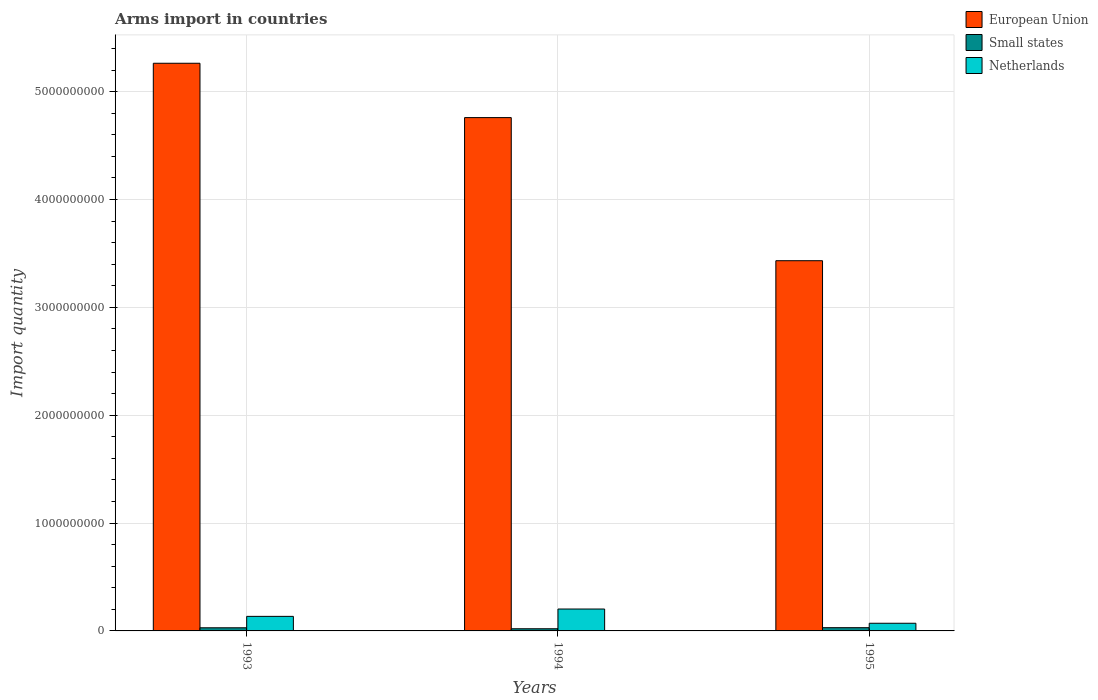How many different coloured bars are there?
Ensure brevity in your answer.  3. Are the number of bars on each tick of the X-axis equal?
Offer a terse response. Yes. What is the label of the 1st group of bars from the left?
Your response must be concise. 1993. What is the total arms import in Small states in 1995?
Keep it short and to the point. 3.00e+07. Across all years, what is the maximum total arms import in Netherlands?
Your answer should be compact. 2.03e+08. Across all years, what is the minimum total arms import in Small states?
Offer a very short reply. 2.00e+07. In which year was the total arms import in Netherlands maximum?
Make the answer very short. 1994. In which year was the total arms import in Small states minimum?
Offer a terse response. 1994. What is the total total arms import in Netherlands in the graph?
Make the answer very short. 4.09e+08. What is the difference between the total arms import in Small states in 1994 and that in 1995?
Provide a short and direct response. -1.00e+07. What is the difference between the total arms import in European Union in 1994 and the total arms import in Small states in 1995?
Your response must be concise. 4.73e+09. What is the average total arms import in Netherlands per year?
Your response must be concise. 1.36e+08. In the year 1993, what is the difference between the total arms import in European Union and total arms import in Netherlands?
Your answer should be compact. 5.13e+09. In how many years, is the total arms import in Netherlands greater than 4600000000?
Your response must be concise. 0. What is the ratio of the total arms import in European Union in 1993 to that in 1994?
Provide a short and direct response. 1.11. Is the difference between the total arms import in European Union in 1993 and 1994 greater than the difference between the total arms import in Netherlands in 1993 and 1994?
Your response must be concise. Yes. What is the difference between the highest and the second highest total arms import in Small states?
Provide a succinct answer. 1.00e+06. What is the difference between the highest and the lowest total arms import in European Union?
Offer a very short reply. 1.83e+09. In how many years, is the total arms import in European Union greater than the average total arms import in European Union taken over all years?
Make the answer very short. 2. Is the sum of the total arms import in Netherlands in 1993 and 1995 greater than the maximum total arms import in Small states across all years?
Ensure brevity in your answer.  Yes. What does the 1st bar from the left in 1994 represents?
Provide a short and direct response. European Union. What does the 1st bar from the right in 1995 represents?
Your answer should be very brief. Netherlands. How many bars are there?
Your answer should be very brief. 9. Are all the bars in the graph horizontal?
Provide a short and direct response. No. How many years are there in the graph?
Provide a succinct answer. 3. What is the difference between two consecutive major ticks on the Y-axis?
Give a very brief answer. 1.00e+09. Are the values on the major ticks of Y-axis written in scientific E-notation?
Give a very brief answer. No. Does the graph contain any zero values?
Offer a terse response. No. How many legend labels are there?
Keep it short and to the point. 3. How are the legend labels stacked?
Offer a very short reply. Vertical. What is the title of the graph?
Give a very brief answer. Arms import in countries. What is the label or title of the Y-axis?
Keep it short and to the point. Import quantity. What is the Import quantity of European Union in 1993?
Your answer should be very brief. 5.26e+09. What is the Import quantity of Small states in 1993?
Give a very brief answer. 2.90e+07. What is the Import quantity of Netherlands in 1993?
Give a very brief answer. 1.35e+08. What is the Import quantity in European Union in 1994?
Your response must be concise. 4.76e+09. What is the Import quantity of Small states in 1994?
Offer a very short reply. 2.00e+07. What is the Import quantity in Netherlands in 1994?
Offer a very short reply. 2.03e+08. What is the Import quantity in European Union in 1995?
Offer a very short reply. 3.43e+09. What is the Import quantity of Small states in 1995?
Ensure brevity in your answer.  3.00e+07. What is the Import quantity in Netherlands in 1995?
Your answer should be compact. 7.10e+07. Across all years, what is the maximum Import quantity in European Union?
Ensure brevity in your answer.  5.26e+09. Across all years, what is the maximum Import quantity in Small states?
Give a very brief answer. 3.00e+07. Across all years, what is the maximum Import quantity in Netherlands?
Offer a terse response. 2.03e+08. Across all years, what is the minimum Import quantity of European Union?
Your answer should be compact. 3.43e+09. Across all years, what is the minimum Import quantity of Small states?
Your response must be concise. 2.00e+07. Across all years, what is the minimum Import quantity of Netherlands?
Provide a succinct answer. 7.10e+07. What is the total Import quantity in European Union in the graph?
Your response must be concise. 1.35e+1. What is the total Import quantity in Small states in the graph?
Make the answer very short. 7.90e+07. What is the total Import quantity in Netherlands in the graph?
Provide a succinct answer. 4.09e+08. What is the difference between the Import quantity in European Union in 1993 and that in 1994?
Ensure brevity in your answer.  5.04e+08. What is the difference between the Import quantity of Small states in 1993 and that in 1994?
Your response must be concise. 9.00e+06. What is the difference between the Import quantity in Netherlands in 1993 and that in 1994?
Your response must be concise. -6.80e+07. What is the difference between the Import quantity in European Union in 1993 and that in 1995?
Offer a terse response. 1.83e+09. What is the difference between the Import quantity in Netherlands in 1993 and that in 1995?
Keep it short and to the point. 6.40e+07. What is the difference between the Import quantity of European Union in 1994 and that in 1995?
Offer a terse response. 1.33e+09. What is the difference between the Import quantity of Small states in 1994 and that in 1995?
Keep it short and to the point. -1.00e+07. What is the difference between the Import quantity of Netherlands in 1994 and that in 1995?
Ensure brevity in your answer.  1.32e+08. What is the difference between the Import quantity in European Union in 1993 and the Import quantity in Small states in 1994?
Your response must be concise. 5.24e+09. What is the difference between the Import quantity in European Union in 1993 and the Import quantity in Netherlands in 1994?
Make the answer very short. 5.06e+09. What is the difference between the Import quantity of Small states in 1993 and the Import quantity of Netherlands in 1994?
Your response must be concise. -1.74e+08. What is the difference between the Import quantity in European Union in 1993 and the Import quantity in Small states in 1995?
Ensure brevity in your answer.  5.23e+09. What is the difference between the Import quantity in European Union in 1993 and the Import quantity in Netherlands in 1995?
Ensure brevity in your answer.  5.19e+09. What is the difference between the Import quantity of Small states in 1993 and the Import quantity of Netherlands in 1995?
Provide a short and direct response. -4.20e+07. What is the difference between the Import quantity of European Union in 1994 and the Import quantity of Small states in 1995?
Your answer should be compact. 4.73e+09. What is the difference between the Import quantity in European Union in 1994 and the Import quantity in Netherlands in 1995?
Provide a succinct answer. 4.69e+09. What is the difference between the Import quantity of Small states in 1994 and the Import quantity of Netherlands in 1995?
Provide a succinct answer. -5.10e+07. What is the average Import quantity in European Union per year?
Provide a succinct answer. 4.49e+09. What is the average Import quantity in Small states per year?
Offer a terse response. 2.63e+07. What is the average Import quantity of Netherlands per year?
Ensure brevity in your answer.  1.36e+08. In the year 1993, what is the difference between the Import quantity in European Union and Import quantity in Small states?
Your answer should be compact. 5.24e+09. In the year 1993, what is the difference between the Import quantity of European Union and Import quantity of Netherlands?
Your answer should be compact. 5.13e+09. In the year 1993, what is the difference between the Import quantity of Small states and Import quantity of Netherlands?
Provide a succinct answer. -1.06e+08. In the year 1994, what is the difference between the Import quantity in European Union and Import quantity in Small states?
Your answer should be very brief. 4.74e+09. In the year 1994, what is the difference between the Import quantity in European Union and Import quantity in Netherlands?
Your response must be concise. 4.56e+09. In the year 1994, what is the difference between the Import quantity of Small states and Import quantity of Netherlands?
Provide a succinct answer. -1.83e+08. In the year 1995, what is the difference between the Import quantity in European Union and Import quantity in Small states?
Offer a very short reply. 3.40e+09. In the year 1995, what is the difference between the Import quantity in European Union and Import quantity in Netherlands?
Provide a succinct answer. 3.36e+09. In the year 1995, what is the difference between the Import quantity of Small states and Import quantity of Netherlands?
Make the answer very short. -4.10e+07. What is the ratio of the Import quantity in European Union in 1993 to that in 1994?
Your answer should be very brief. 1.11. What is the ratio of the Import quantity of Small states in 1993 to that in 1994?
Ensure brevity in your answer.  1.45. What is the ratio of the Import quantity of Netherlands in 1993 to that in 1994?
Offer a very short reply. 0.67. What is the ratio of the Import quantity in European Union in 1993 to that in 1995?
Offer a terse response. 1.53. What is the ratio of the Import quantity of Small states in 1993 to that in 1995?
Offer a very short reply. 0.97. What is the ratio of the Import quantity in Netherlands in 1993 to that in 1995?
Make the answer very short. 1.9. What is the ratio of the Import quantity in European Union in 1994 to that in 1995?
Provide a succinct answer. 1.39. What is the ratio of the Import quantity in Netherlands in 1994 to that in 1995?
Provide a short and direct response. 2.86. What is the difference between the highest and the second highest Import quantity of European Union?
Provide a succinct answer. 5.04e+08. What is the difference between the highest and the second highest Import quantity in Netherlands?
Ensure brevity in your answer.  6.80e+07. What is the difference between the highest and the lowest Import quantity of European Union?
Ensure brevity in your answer.  1.83e+09. What is the difference between the highest and the lowest Import quantity in Small states?
Your response must be concise. 1.00e+07. What is the difference between the highest and the lowest Import quantity of Netherlands?
Provide a succinct answer. 1.32e+08. 